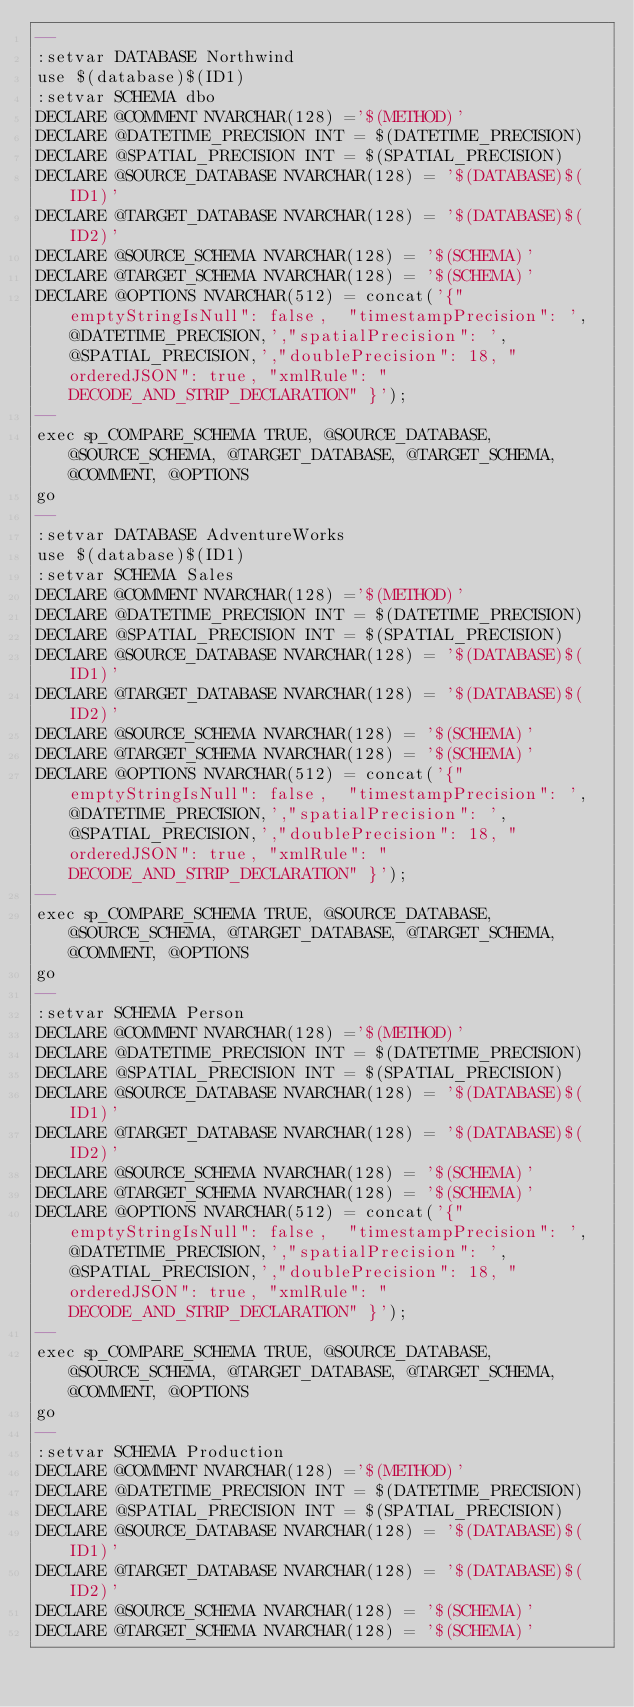<code> <loc_0><loc_0><loc_500><loc_500><_SQL_>--
:setvar DATABASE Northwind
use $(database)$(ID1)
:setvar SCHEMA dbo
DECLARE @COMMENT NVARCHAR(128) ='$(METHOD)'
DECLARE @DATETIME_PRECISION INT = $(DATETIME_PRECISION)
DECLARE @SPATIAL_PRECISION INT = $(SPATIAL_PRECISION)
DECLARE @SOURCE_DATABASE NVARCHAR(128) = '$(DATABASE)$(ID1)'
DECLARE @TARGET_DATABASE NVARCHAR(128) = '$(DATABASE)$(ID2)'
DECLARE @SOURCE_SCHEMA NVARCHAR(128) = '$(SCHEMA)'
DECLARE @TARGET_SCHEMA NVARCHAR(128) = '$(SCHEMA)'
DECLARE @OPTIONS NVARCHAR(512) = concat('{"emptyStringIsNull": false,  "timestampPrecision": ',@DATETIME_PRECISION,',"spatialPrecision": ',@SPATIAL_PRECISION,',"doublePrecision": 18, "orderedJSON": true, "xmlRule": "DECODE_AND_STRIP_DECLARATION" }');
--
exec sp_COMPARE_SCHEMA TRUE, @SOURCE_DATABASE, @SOURCE_SCHEMA, @TARGET_DATABASE, @TARGET_SCHEMA, @COMMENT, @OPTIONS
go
--
:setvar DATABASE AdventureWorks
use $(database)$(ID1)
:setvar SCHEMA Sales
DECLARE @COMMENT NVARCHAR(128) ='$(METHOD)'
DECLARE @DATETIME_PRECISION INT = $(DATETIME_PRECISION)
DECLARE @SPATIAL_PRECISION INT = $(SPATIAL_PRECISION)
DECLARE @SOURCE_DATABASE NVARCHAR(128) = '$(DATABASE)$(ID1)'
DECLARE @TARGET_DATABASE NVARCHAR(128) = '$(DATABASE)$(ID2)'
DECLARE @SOURCE_SCHEMA NVARCHAR(128) = '$(SCHEMA)'
DECLARE @TARGET_SCHEMA NVARCHAR(128) = '$(SCHEMA)'
DECLARE @OPTIONS NVARCHAR(512) = concat('{"emptyStringIsNull": false,  "timestampPrecision": ',@DATETIME_PRECISION,',"spatialPrecision": ',@SPATIAL_PRECISION,',"doublePrecision": 18, "orderedJSON": true, "xmlRule": "DECODE_AND_STRIP_DECLARATION" }');
--
exec sp_COMPARE_SCHEMA TRUE, @SOURCE_DATABASE, @SOURCE_SCHEMA, @TARGET_DATABASE, @TARGET_SCHEMA, @COMMENT, @OPTIONS
go
--
:setvar SCHEMA Person
DECLARE @COMMENT NVARCHAR(128) ='$(METHOD)'
DECLARE @DATETIME_PRECISION INT = $(DATETIME_PRECISION)
DECLARE @SPATIAL_PRECISION INT = $(SPATIAL_PRECISION)
DECLARE @SOURCE_DATABASE NVARCHAR(128) = '$(DATABASE)$(ID1)'
DECLARE @TARGET_DATABASE NVARCHAR(128) = '$(DATABASE)$(ID2)'
DECLARE @SOURCE_SCHEMA NVARCHAR(128) = '$(SCHEMA)'
DECLARE @TARGET_SCHEMA NVARCHAR(128) = '$(SCHEMA)'
DECLARE @OPTIONS NVARCHAR(512) = concat('{"emptyStringIsNull": false,  "timestampPrecision": ',@DATETIME_PRECISION,',"spatialPrecision": ',@SPATIAL_PRECISION,',"doublePrecision": 18, "orderedJSON": true, "xmlRule": "DECODE_AND_STRIP_DECLARATION" }');
--
exec sp_COMPARE_SCHEMA TRUE, @SOURCE_DATABASE, @SOURCE_SCHEMA, @TARGET_DATABASE, @TARGET_SCHEMA, @COMMENT, @OPTIONS
go
--
:setvar SCHEMA Production
DECLARE @COMMENT NVARCHAR(128) ='$(METHOD)'
DECLARE @DATETIME_PRECISION INT = $(DATETIME_PRECISION)
DECLARE @SPATIAL_PRECISION INT = $(SPATIAL_PRECISION)
DECLARE @SOURCE_DATABASE NVARCHAR(128) = '$(DATABASE)$(ID1)'
DECLARE @TARGET_DATABASE NVARCHAR(128) = '$(DATABASE)$(ID2)'
DECLARE @SOURCE_SCHEMA NVARCHAR(128) = '$(SCHEMA)'
DECLARE @TARGET_SCHEMA NVARCHAR(128) = '$(SCHEMA)'</code> 